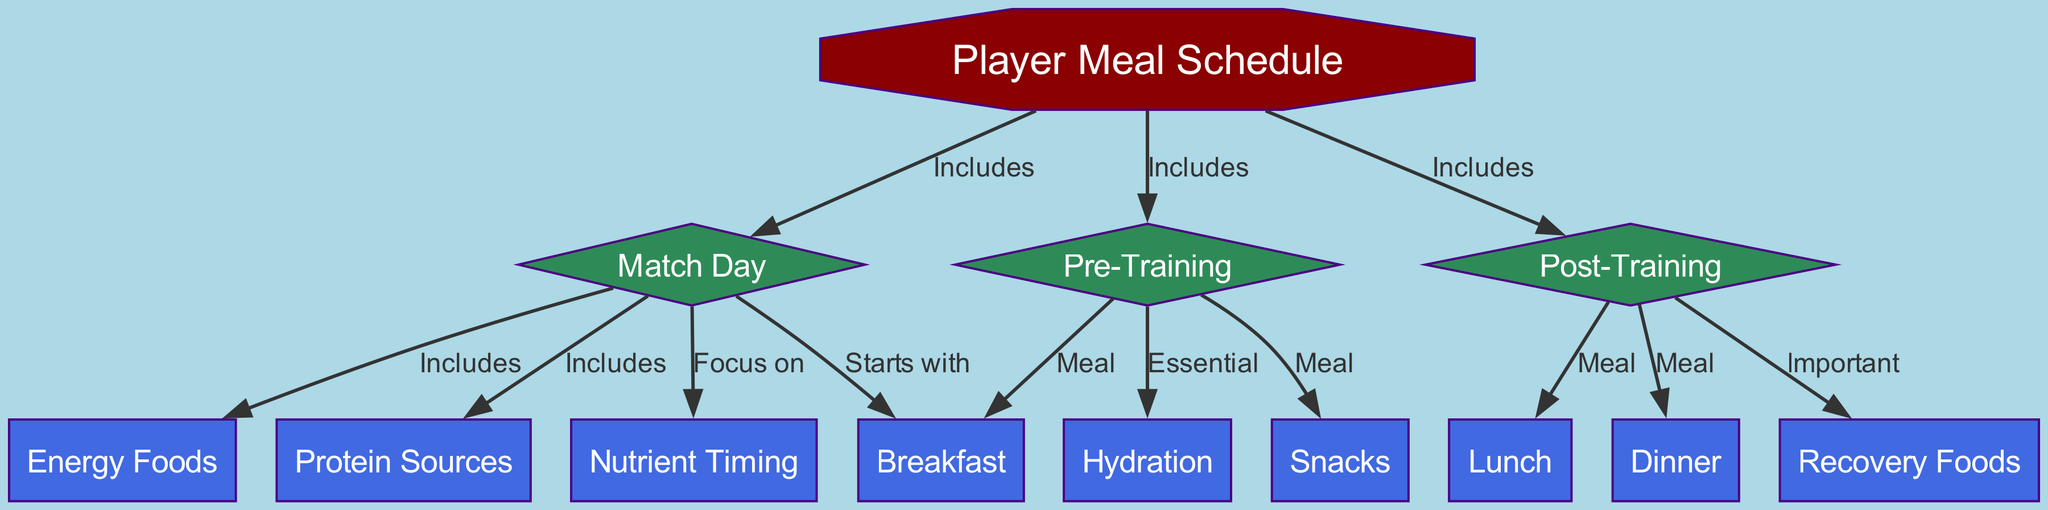What are the three main categories of meal times included in the player's meal schedule? The diagram shows three meal times categorized under Pre-Training, Post-Training, and Match Day. Each of these categories has specific meals associated with them.
Answer: Pre-Training, Post-Training, Match Day How many edges are there in the diagram? To find the number of edges, we count each relationship between nodes. The diagram has a total of 10 edges connecting various nodes, indicating the relationships between meal times and other relevant components.
Answer: 10 What meal is included in the Post-Training category? The diagram explicitly connects Post-Training with lunch, dinner, and recovery foods. Since we are looking for a meal included in this category, one of them is lunch.
Answer: Lunch Which meal starts the Match Day? According to the diagram, the connection from Match Day to Breakfast indicates that Breakfast is the first meal on this day.
Answer: Breakfast What is emphasized in the Match Day category? The Match Day category highlights the focus on nutrient timing, as shown by the connection labeled 'Focus on' from Match Day to Nutrient Timing.
Answer: Nutrient Timing Which meal types are categorized under Pre-Training? The diagram shows that the Pre-Training category includes Breakfast and Snacks, linking these two meal types directly from Pre-Training.
Answer: Breakfast, Snacks What is the importance of Recovery Foods in the Post-Training category? The diagram states that Recovery Foods are important after training, indicating their role in recovery as directly linked from Post-Training. This shows how players should prioritize these foods for optimal recovery.
Answer: Important What significant hydration-related factor is notable in the Pre-Training stage? The diagram specifies Hydration as essential during the Pre-Training category, indicating that players must focus on this aspect for their performance.
Answer: Essential 